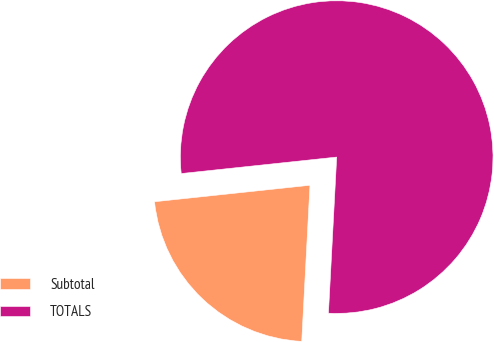Convert chart. <chart><loc_0><loc_0><loc_500><loc_500><pie_chart><fcel>Subtotal<fcel>TOTALS<nl><fcel>22.48%<fcel>77.52%<nl></chart> 